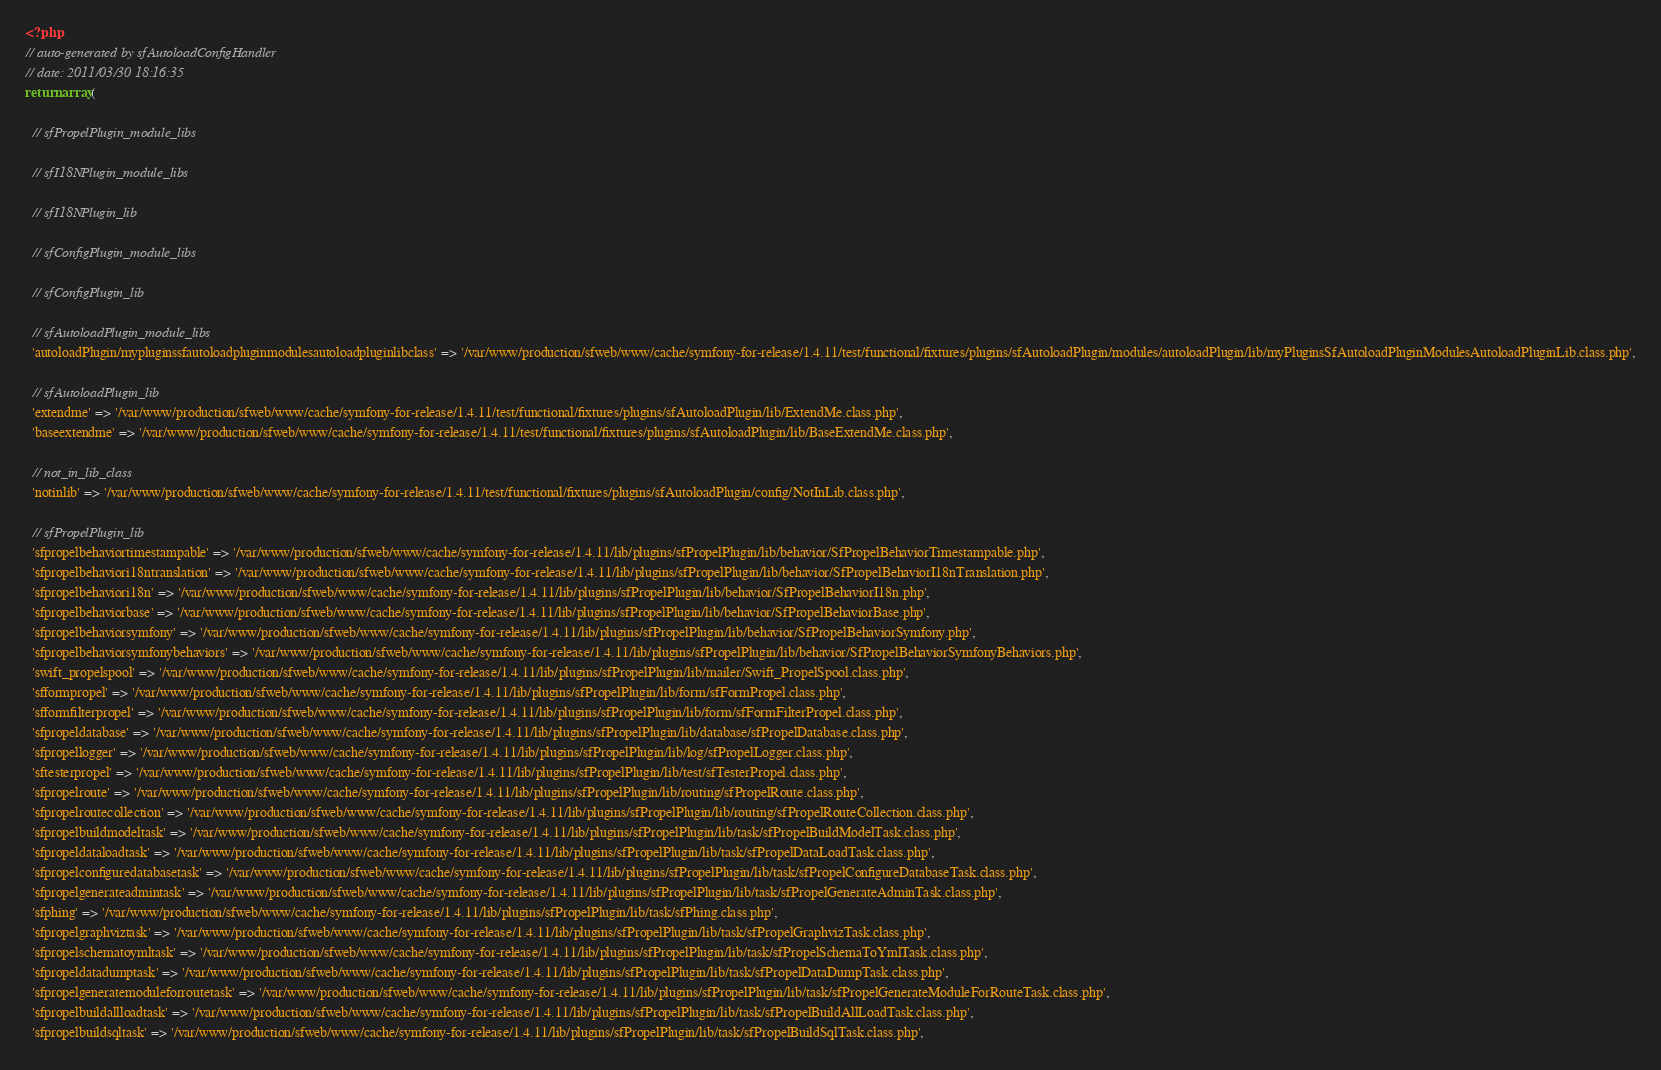Convert code to text. <code><loc_0><loc_0><loc_500><loc_500><_PHP_><?php
// auto-generated by sfAutoloadConfigHandler
// date: 2011/03/30 18:16:35
return array(

  // sfPropelPlugin_module_libs

  // sfI18NPlugin_module_libs

  // sfI18NPlugin_lib

  // sfConfigPlugin_module_libs

  // sfConfigPlugin_lib

  // sfAutoloadPlugin_module_libs
  'autoloadPlugin/mypluginssfautoloadpluginmodulesautoloadpluginlibclass' => '/var/www/production/sfweb/www/cache/symfony-for-release/1.4.11/test/functional/fixtures/plugins/sfAutoloadPlugin/modules/autoloadPlugin/lib/myPluginsSfAutoloadPluginModulesAutoloadPluginLib.class.php',

  // sfAutoloadPlugin_lib
  'extendme' => '/var/www/production/sfweb/www/cache/symfony-for-release/1.4.11/test/functional/fixtures/plugins/sfAutoloadPlugin/lib/ExtendMe.class.php',
  'baseextendme' => '/var/www/production/sfweb/www/cache/symfony-for-release/1.4.11/test/functional/fixtures/plugins/sfAutoloadPlugin/lib/BaseExtendMe.class.php',

  // not_in_lib_class
  'notinlib' => '/var/www/production/sfweb/www/cache/symfony-for-release/1.4.11/test/functional/fixtures/plugins/sfAutoloadPlugin/config/NotInLib.class.php',

  // sfPropelPlugin_lib
  'sfpropelbehaviortimestampable' => '/var/www/production/sfweb/www/cache/symfony-for-release/1.4.11/lib/plugins/sfPropelPlugin/lib/behavior/SfPropelBehaviorTimestampable.php',
  'sfpropelbehaviori18ntranslation' => '/var/www/production/sfweb/www/cache/symfony-for-release/1.4.11/lib/plugins/sfPropelPlugin/lib/behavior/SfPropelBehaviorI18nTranslation.php',
  'sfpropelbehaviori18n' => '/var/www/production/sfweb/www/cache/symfony-for-release/1.4.11/lib/plugins/sfPropelPlugin/lib/behavior/SfPropelBehaviorI18n.php',
  'sfpropelbehaviorbase' => '/var/www/production/sfweb/www/cache/symfony-for-release/1.4.11/lib/plugins/sfPropelPlugin/lib/behavior/SfPropelBehaviorBase.php',
  'sfpropelbehaviorsymfony' => '/var/www/production/sfweb/www/cache/symfony-for-release/1.4.11/lib/plugins/sfPropelPlugin/lib/behavior/SfPropelBehaviorSymfony.php',
  'sfpropelbehaviorsymfonybehaviors' => '/var/www/production/sfweb/www/cache/symfony-for-release/1.4.11/lib/plugins/sfPropelPlugin/lib/behavior/SfPropelBehaviorSymfonyBehaviors.php',
  'swift_propelspool' => '/var/www/production/sfweb/www/cache/symfony-for-release/1.4.11/lib/plugins/sfPropelPlugin/lib/mailer/Swift_PropelSpool.class.php',
  'sfformpropel' => '/var/www/production/sfweb/www/cache/symfony-for-release/1.4.11/lib/plugins/sfPropelPlugin/lib/form/sfFormPropel.class.php',
  'sfformfilterpropel' => '/var/www/production/sfweb/www/cache/symfony-for-release/1.4.11/lib/plugins/sfPropelPlugin/lib/form/sfFormFilterPropel.class.php',
  'sfpropeldatabase' => '/var/www/production/sfweb/www/cache/symfony-for-release/1.4.11/lib/plugins/sfPropelPlugin/lib/database/sfPropelDatabase.class.php',
  'sfpropellogger' => '/var/www/production/sfweb/www/cache/symfony-for-release/1.4.11/lib/plugins/sfPropelPlugin/lib/log/sfPropelLogger.class.php',
  'sftesterpropel' => '/var/www/production/sfweb/www/cache/symfony-for-release/1.4.11/lib/plugins/sfPropelPlugin/lib/test/sfTesterPropel.class.php',
  'sfpropelroute' => '/var/www/production/sfweb/www/cache/symfony-for-release/1.4.11/lib/plugins/sfPropelPlugin/lib/routing/sfPropelRoute.class.php',
  'sfpropelroutecollection' => '/var/www/production/sfweb/www/cache/symfony-for-release/1.4.11/lib/plugins/sfPropelPlugin/lib/routing/sfPropelRouteCollection.class.php',
  'sfpropelbuildmodeltask' => '/var/www/production/sfweb/www/cache/symfony-for-release/1.4.11/lib/plugins/sfPropelPlugin/lib/task/sfPropelBuildModelTask.class.php',
  'sfpropeldataloadtask' => '/var/www/production/sfweb/www/cache/symfony-for-release/1.4.11/lib/plugins/sfPropelPlugin/lib/task/sfPropelDataLoadTask.class.php',
  'sfpropelconfiguredatabasetask' => '/var/www/production/sfweb/www/cache/symfony-for-release/1.4.11/lib/plugins/sfPropelPlugin/lib/task/sfPropelConfigureDatabaseTask.class.php',
  'sfpropelgenerateadmintask' => '/var/www/production/sfweb/www/cache/symfony-for-release/1.4.11/lib/plugins/sfPropelPlugin/lib/task/sfPropelGenerateAdminTask.class.php',
  'sfphing' => '/var/www/production/sfweb/www/cache/symfony-for-release/1.4.11/lib/plugins/sfPropelPlugin/lib/task/sfPhing.class.php',
  'sfpropelgraphviztask' => '/var/www/production/sfweb/www/cache/symfony-for-release/1.4.11/lib/plugins/sfPropelPlugin/lib/task/sfPropelGraphvizTask.class.php',
  'sfpropelschematoymltask' => '/var/www/production/sfweb/www/cache/symfony-for-release/1.4.11/lib/plugins/sfPropelPlugin/lib/task/sfPropelSchemaToYmlTask.class.php',
  'sfpropeldatadumptask' => '/var/www/production/sfweb/www/cache/symfony-for-release/1.4.11/lib/plugins/sfPropelPlugin/lib/task/sfPropelDataDumpTask.class.php',
  'sfpropelgeneratemoduleforroutetask' => '/var/www/production/sfweb/www/cache/symfony-for-release/1.4.11/lib/plugins/sfPropelPlugin/lib/task/sfPropelGenerateModuleForRouteTask.class.php',
  'sfpropelbuildallloadtask' => '/var/www/production/sfweb/www/cache/symfony-for-release/1.4.11/lib/plugins/sfPropelPlugin/lib/task/sfPropelBuildAllLoadTask.class.php',
  'sfpropelbuildsqltask' => '/var/www/production/sfweb/www/cache/symfony-for-release/1.4.11/lib/plugins/sfPropelPlugin/lib/task/sfPropelBuildSqlTask.class.php',</code> 